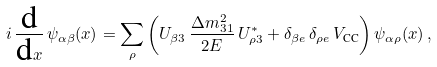Convert formula to latex. <formula><loc_0><loc_0><loc_500><loc_500>i \, \frac { \text {d} } { \text {d} x } \, \psi _ { \alpha \beta } ( x ) = \sum _ { \rho } \left ( U _ { \beta 3 } \, \frac { \Delta { m } ^ { 2 } _ { 3 1 } } { 2 E } \, U _ { \rho 3 } ^ { * } + \delta _ { \beta e } \, \delta _ { \rho e } \, V _ { \text {CC} } \right ) \psi _ { \alpha \rho } ( x ) \, ,</formula> 